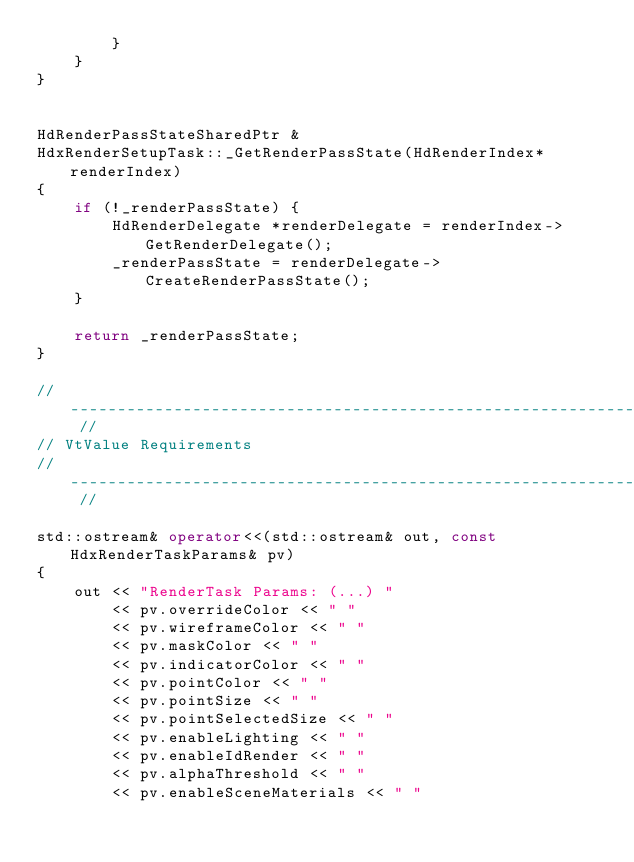Convert code to text. <code><loc_0><loc_0><loc_500><loc_500><_C++_>        }
    }
}


HdRenderPassStateSharedPtr &
HdxRenderSetupTask::_GetRenderPassState(HdRenderIndex* renderIndex)
{
    if (!_renderPassState) {
        HdRenderDelegate *renderDelegate = renderIndex->GetRenderDelegate();
        _renderPassState = renderDelegate->CreateRenderPassState();
    }

    return _renderPassState;
}

// --------------------------------------------------------------------------- //
// VtValue Requirements
// --------------------------------------------------------------------------- //

std::ostream& operator<<(std::ostream& out, const HdxRenderTaskParams& pv)
{
    out << "RenderTask Params: (...) " 
        << pv.overrideColor << " " 
        << pv.wireframeColor << " " 
        << pv.maskColor << " " 
        << pv.indicatorColor << " " 
        << pv.pointColor << " "
        << pv.pointSize << " "
        << pv.pointSelectedSize << " "
        << pv.enableLighting << " "
        << pv.enableIdRender << " "
        << pv.alphaThreshold << " "
        << pv.enableSceneMaterials << " "</code> 